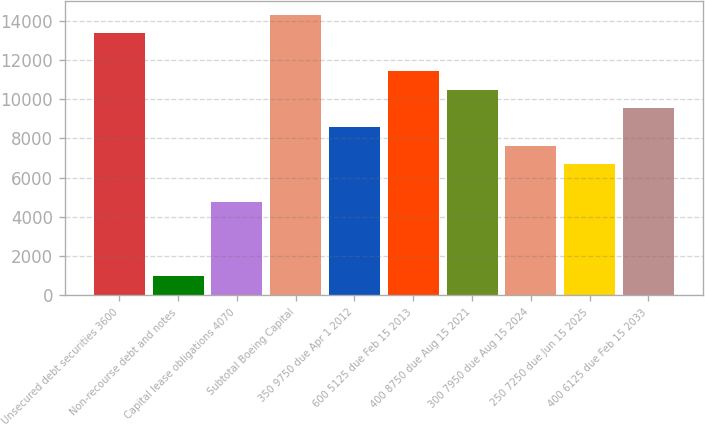Convert chart to OTSL. <chart><loc_0><loc_0><loc_500><loc_500><bar_chart><fcel>Unsecured debt securities 3600<fcel>Non-recourse debt and notes<fcel>Capital lease obligations 4070<fcel>Subtotal Boeing Capital<fcel>350 9750 due Apr 1 2012<fcel>600 5125 due Feb 15 2013<fcel>400 8750 due Aug 15 2021<fcel>300 7950 due Aug 15 2024<fcel>250 7250 due Jun 15 2025<fcel>400 6125 due Feb 15 2033<nl><fcel>13348.8<fcel>963.7<fcel>4774.5<fcel>14301.5<fcel>8585.3<fcel>11443.4<fcel>10490.7<fcel>7632.6<fcel>6679.9<fcel>9538<nl></chart> 